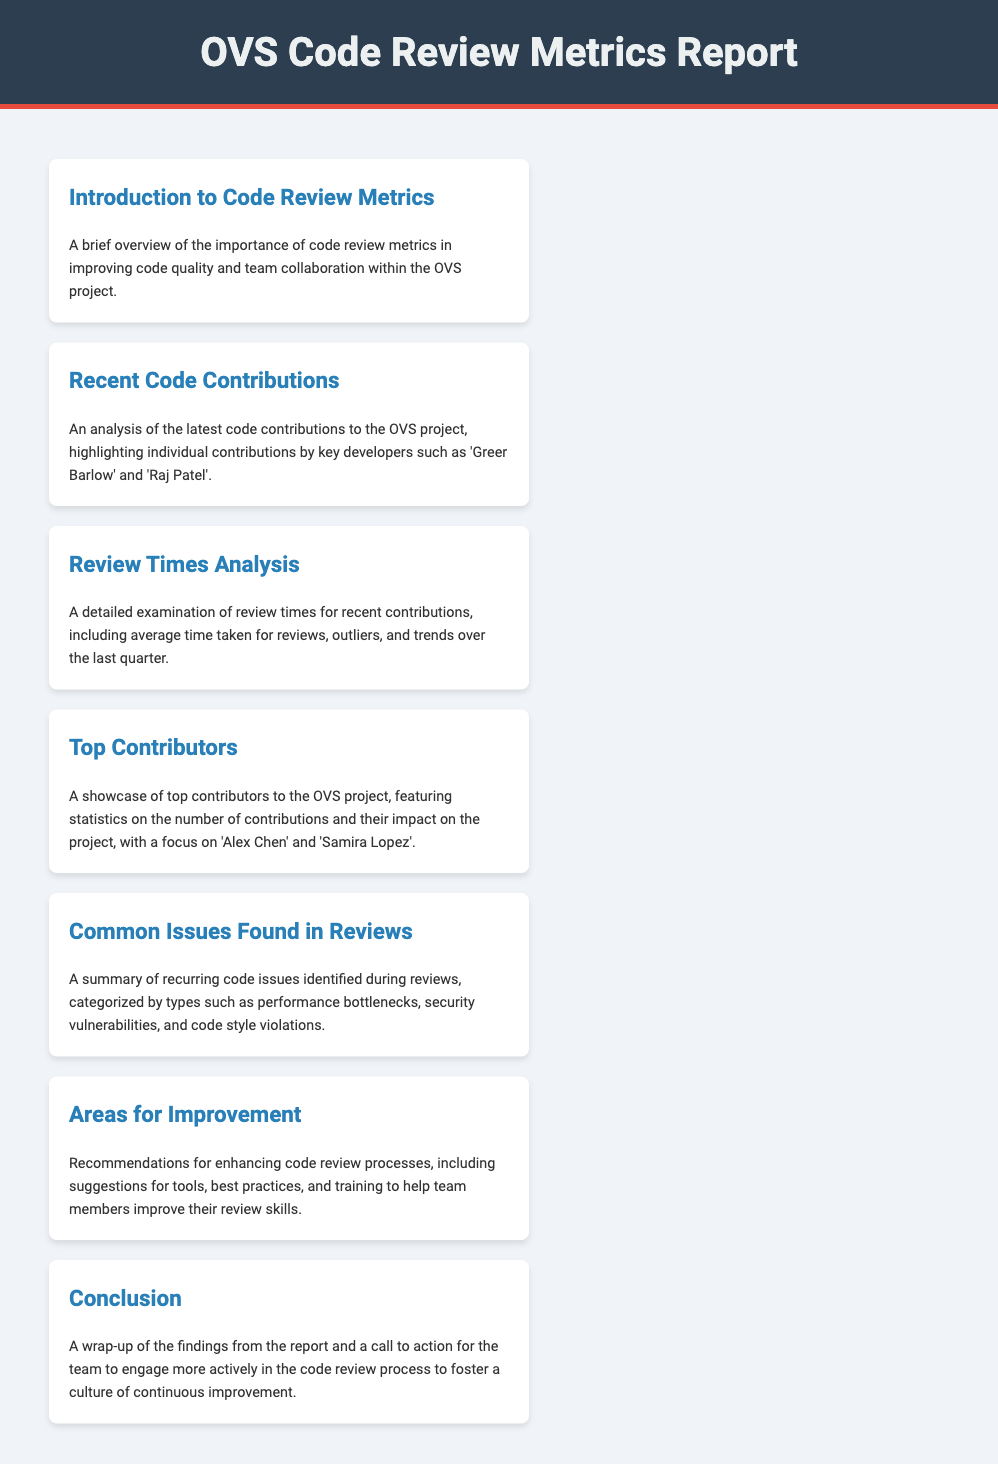What is the title of the report? The title of the report is indicated in the header of the document, which is "OVS Code Review Metrics Report."
Answer: OVS Code Review Metrics Report Who are two key developers mentioned in recent contributions? The document highlights individual contributions by key developers, specifically 'Greer Barlow' and 'Raj Patel.'
Answer: Greer Barlow and Raj Patel What section addresses recurring code issues? The section that summarizes recurring code issues is titled "Common Issues Found in Reviews."
Answer: Common Issues Found in Reviews Which two contributors are showcased for their contributions? The document features statistics on contributions from 'Alex Chen' and 'Samira Lopez' in the "Top Contributors" section.
Answer: Alex Chen and Samira Lopez What is the main focus of the "Areas for Improvement" section? This section offers recommendations for enhancing code review processes, including tools, best practices, and training for team members.
Answer: Recommendations for enhancing code review processes What color is the header background? The header background color of the document is specified in the style section, which is a dark shade represented by the hex code #2c3e50.
Answer: Dark blue What is highlighted in the "Review Times Analysis" section? The "Review Times Analysis" section examines various aspects of review times, including average time taken for reviews and trends over the last quarter.
Answer: Average time taken for reviews What is encouraged in the conclusion? The conclusion encourages the team to engage more actively in the code review process to foster a culture of continuous improvement.
Answer: Engage more actively in the code review process 